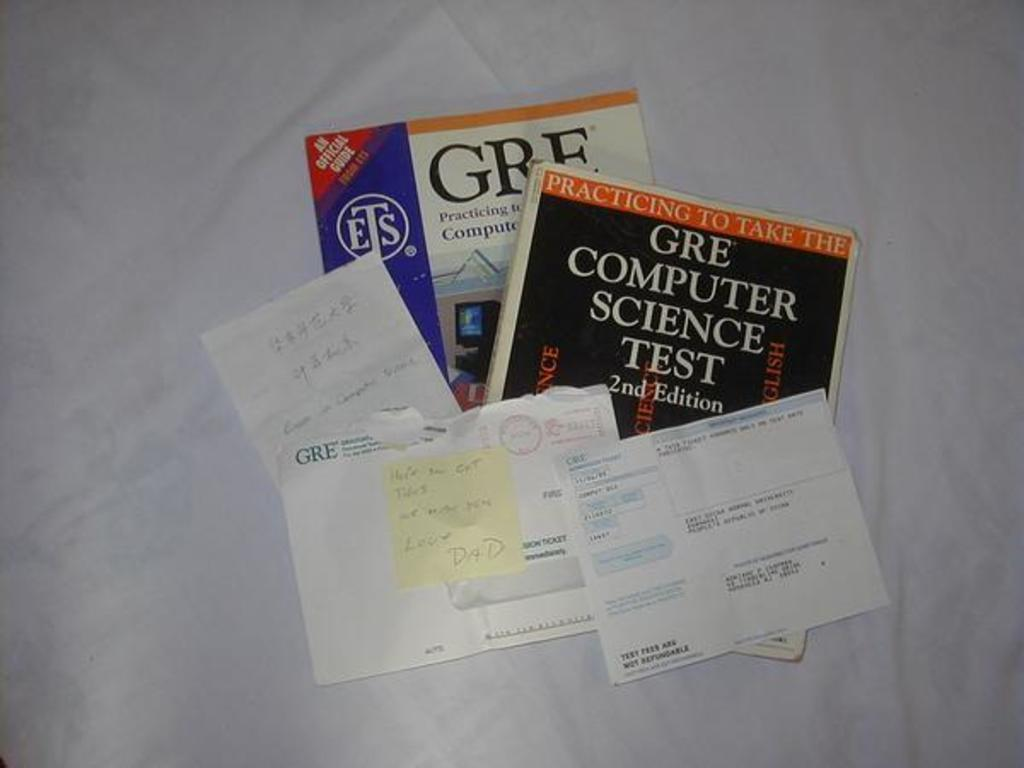<image>
Relay a brief, clear account of the picture shown. Two books for GRE Computer Science Tests placed under some letters. 